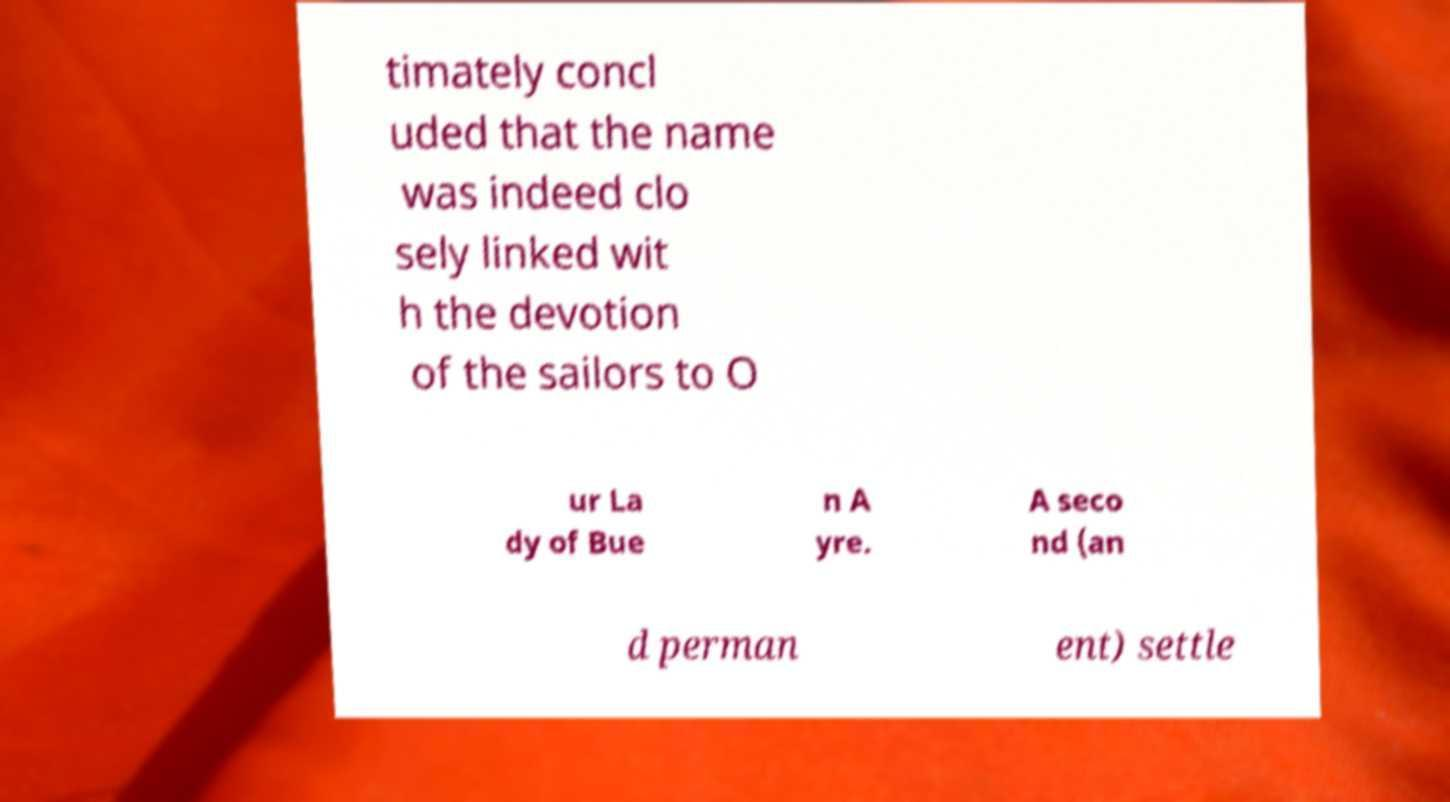Please read and relay the text visible in this image. What does it say? timately concl uded that the name was indeed clo sely linked wit h the devotion of the sailors to O ur La dy of Bue n A yre. A seco nd (an d perman ent) settle 